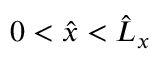<formula> <loc_0><loc_0><loc_500><loc_500>0 < \hat { x } < \hat { L } _ { x }</formula> 